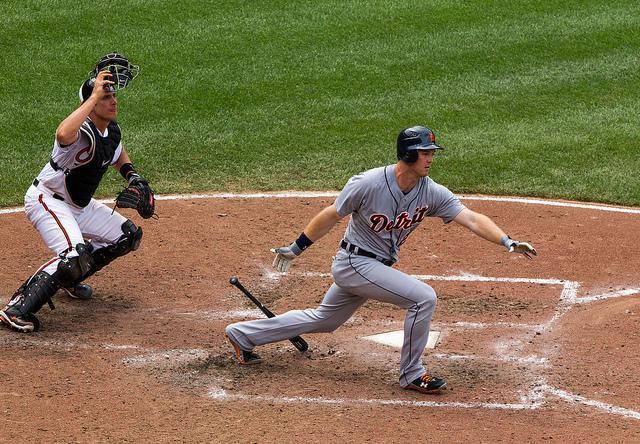How many people are in the photo?
Give a very brief answer. 2. 